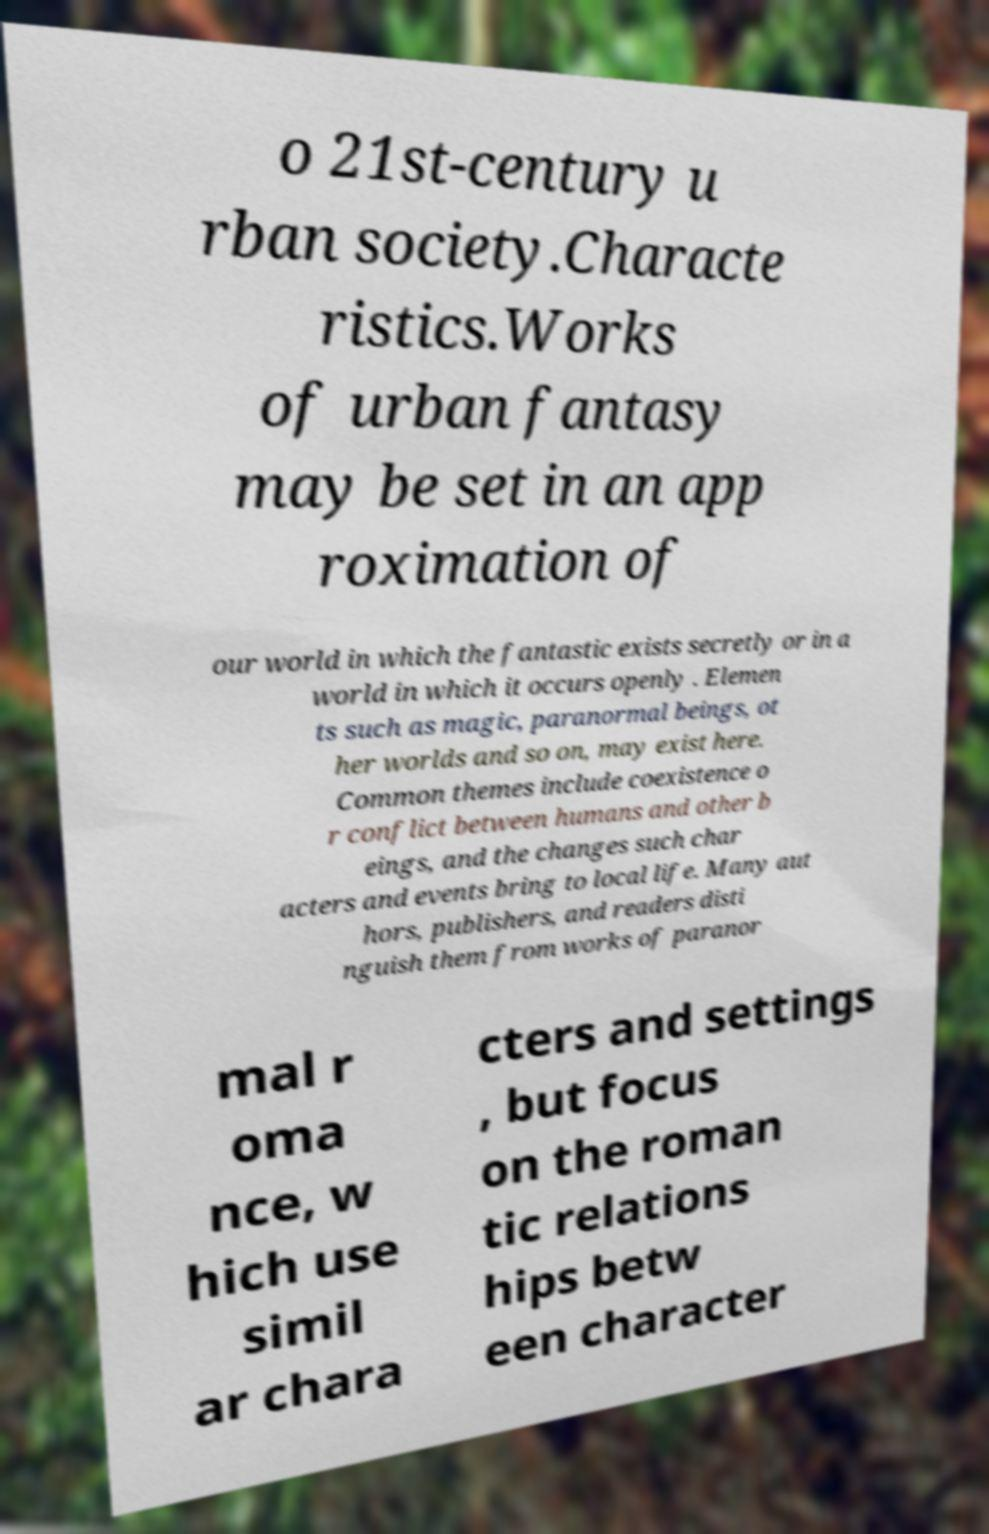There's text embedded in this image that I need extracted. Can you transcribe it verbatim? o 21st-century u rban society.Characte ristics.Works of urban fantasy may be set in an app roximation of our world in which the fantastic exists secretly or in a world in which it occurs openly . Elemen ts such as magic, paranormal beings, ot her worlds and so on, may exist here. Common themes include coexistence o r conflict between humans and other b eings, and the changes such char acters and events bring to local life. Many aut hors, publishers, and readers disti nguish them from works of paranor mal r oma nce, w hich use simil ar chara cters and settings , but focus on the roman tic relations hips betw een character 